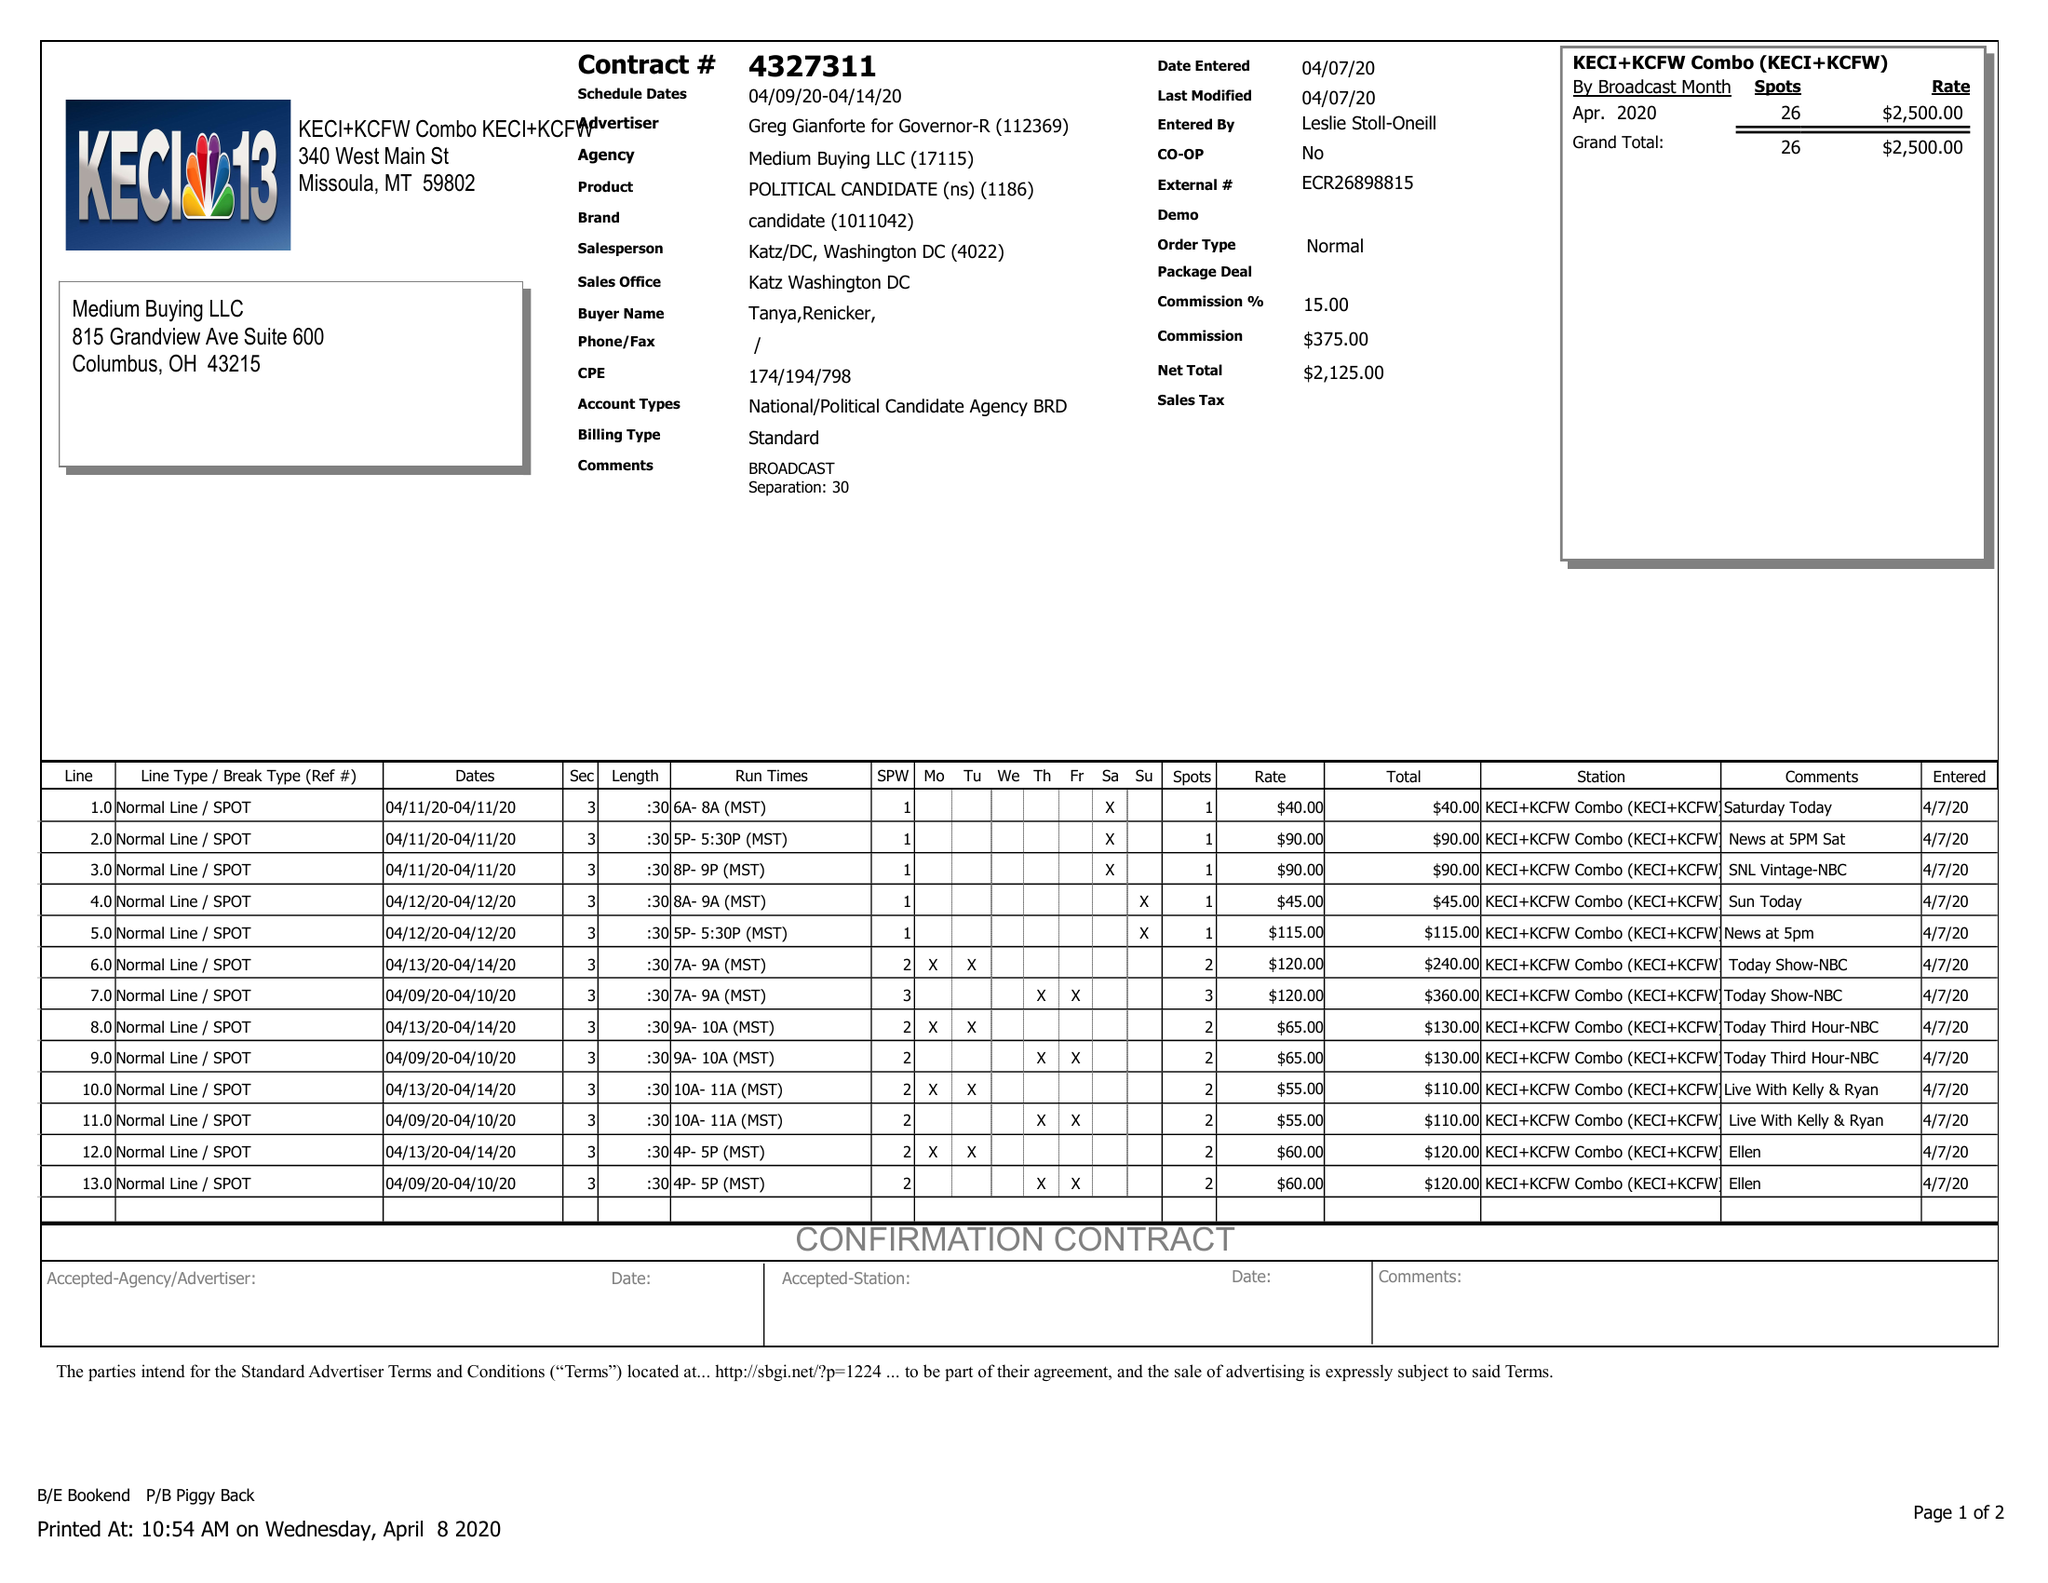What is the value for the contract_num?
Answer the question using a single word or phrase. 4327311 